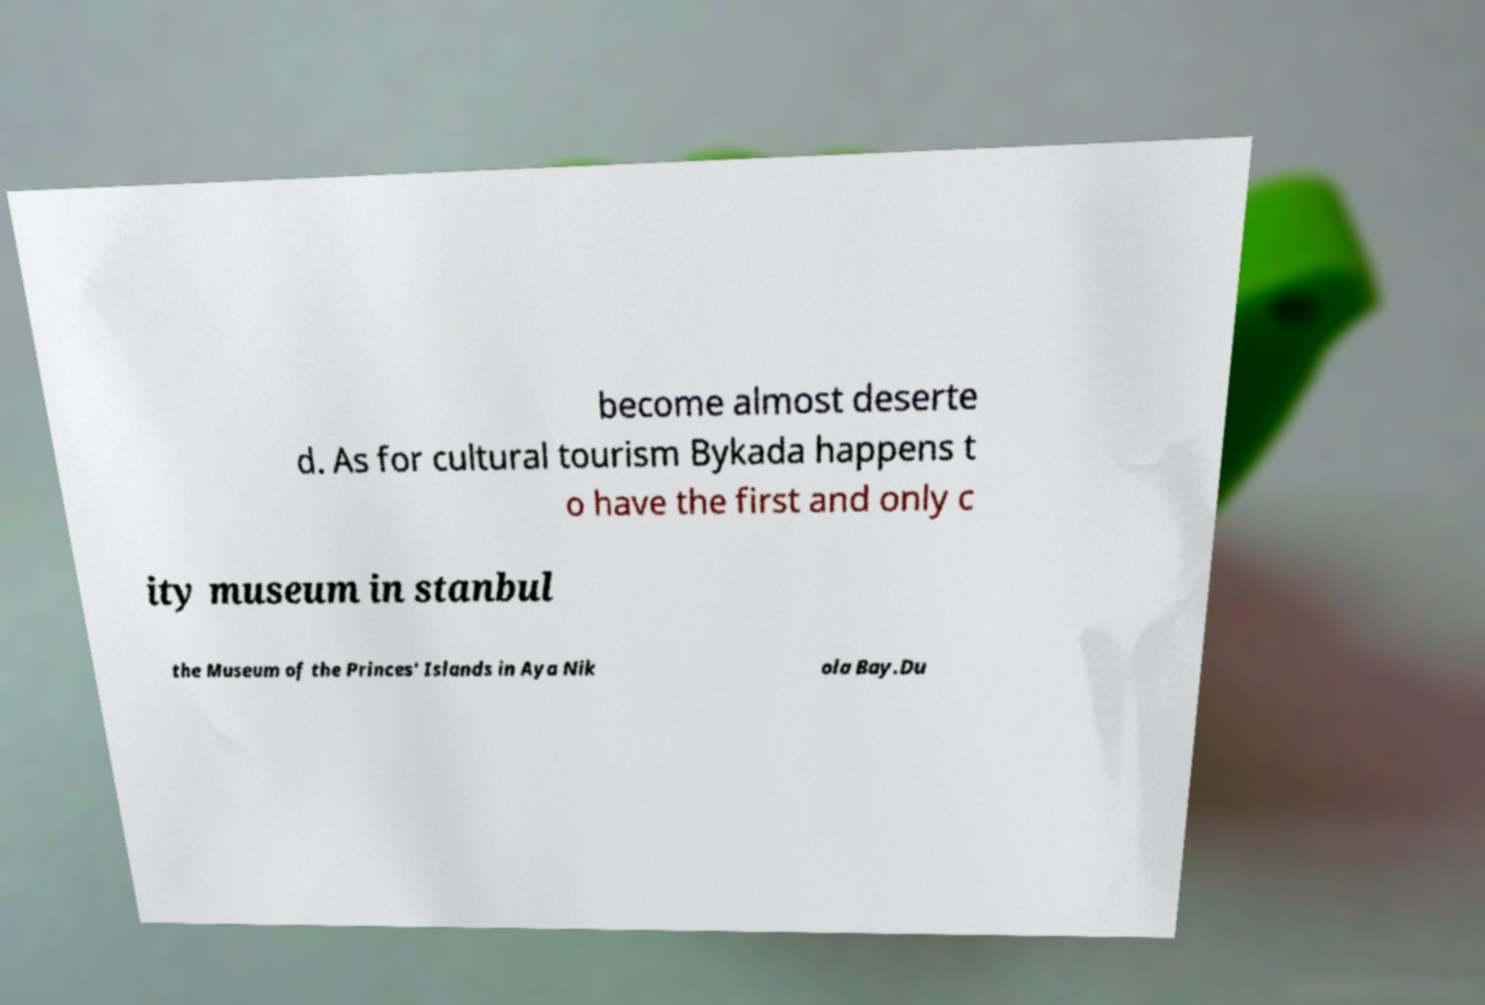Can you accurately transcribe the text from the provided image for me? become almost deserte d. As for cultural tourism Bykada happens t o have the first and only c ity museum in stanbul the Museum of the Princes' Islands in Aya Nik ola Bay.Du 